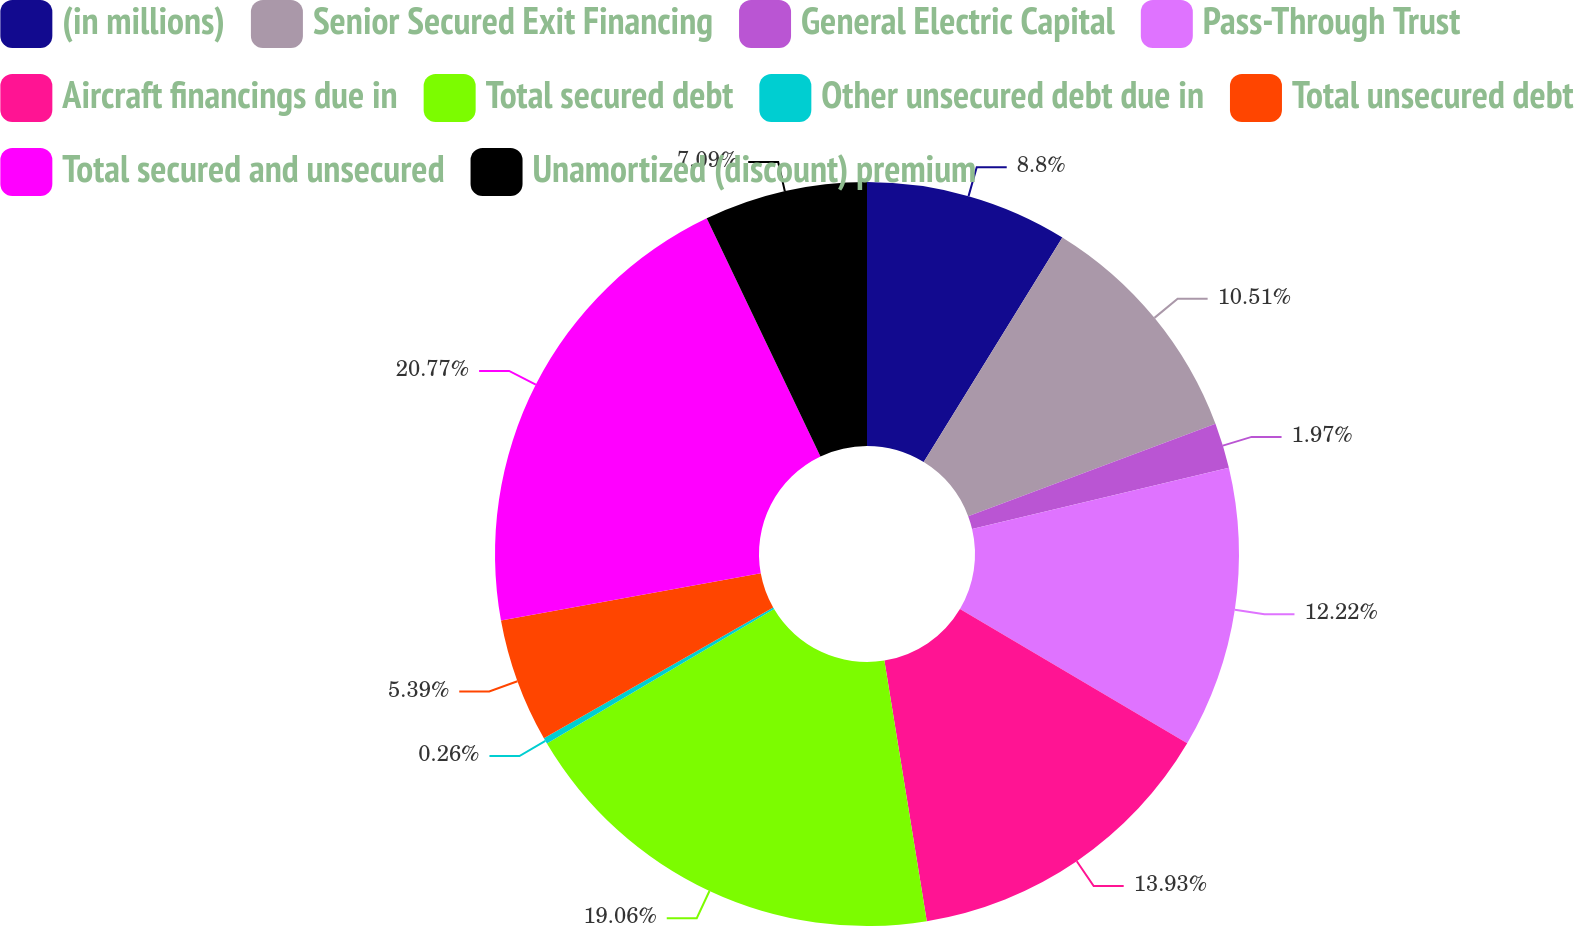Convert chart to OTSL. <chart><loc_0><loc_0><loc_500><loc_500><pie_chart><fcel>(in millions)<fcel>Senior Secured Exit Financing<fcel>General Electric Capital<fcel>Pass-Through Trust<fcel>Aircraft financings due in<fcel>Total secured debt<fcel>Other unsecured debt due in<fcel>Total unsecured debt<fcel>Total secured and unsecured<fcel>Unamortized (discount) premium<nl><fcel>8.8%<fcel>10.51%<fcel>1.97%<fcel>12.22%<fcel>13.93%<fcel>19.06%<fcel>0.26%<fcel>5.39%<fcel>20.77%<fcel>7.09%<nl></chart> 